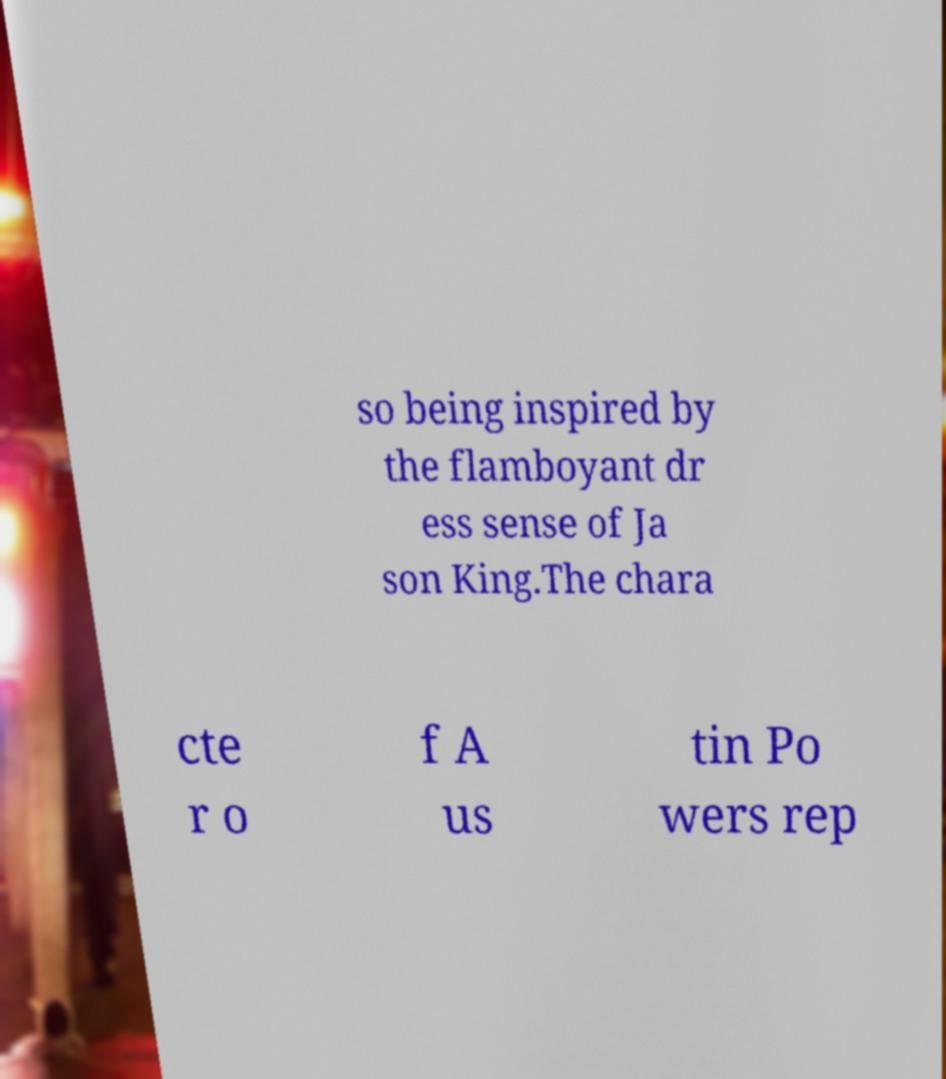Please read and relay the text visible in this image. What does it say? so being inspired by the flamboyant dr ess sense of Ja son King.The chara cte r o f A us tin Po wers rep 